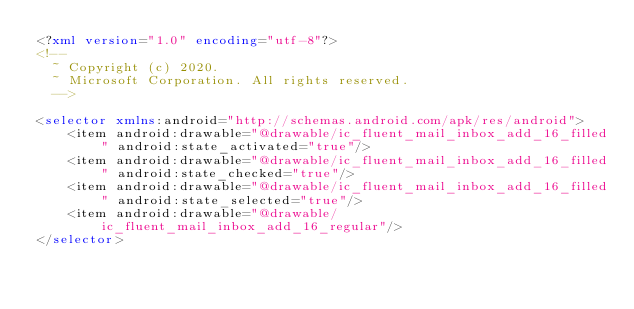Convert code to text. <code><loc_0><loc_0><loc_500><loc_500><_XML_><?xml version="1.0" encoding="utf-8"?>
<!--
  ~ Copyright (c) 2020.
  ~ Microsoft Corporation. All rights reserved.
  -->

<selector xmlns:android="http://schemas.android.com/apk/res/android">
    <item android:drawable="@drawable/ic_fluent_mail_inbox_add_16_filled" android:state_activated="true"/>
    <item android:drawable="@drawable/ic_fluent_mail_inbox_add_16_filled" android:state_checked="true"/>
    <item android:drawable="@drawable/ic_fluent_mail_inbox_add_16_filled" android:state_selected="true"/>
    <item android:drawable="@drawable/ic_fluent_mail_inbox_add_16_regular"/>
</selector>
</code> 